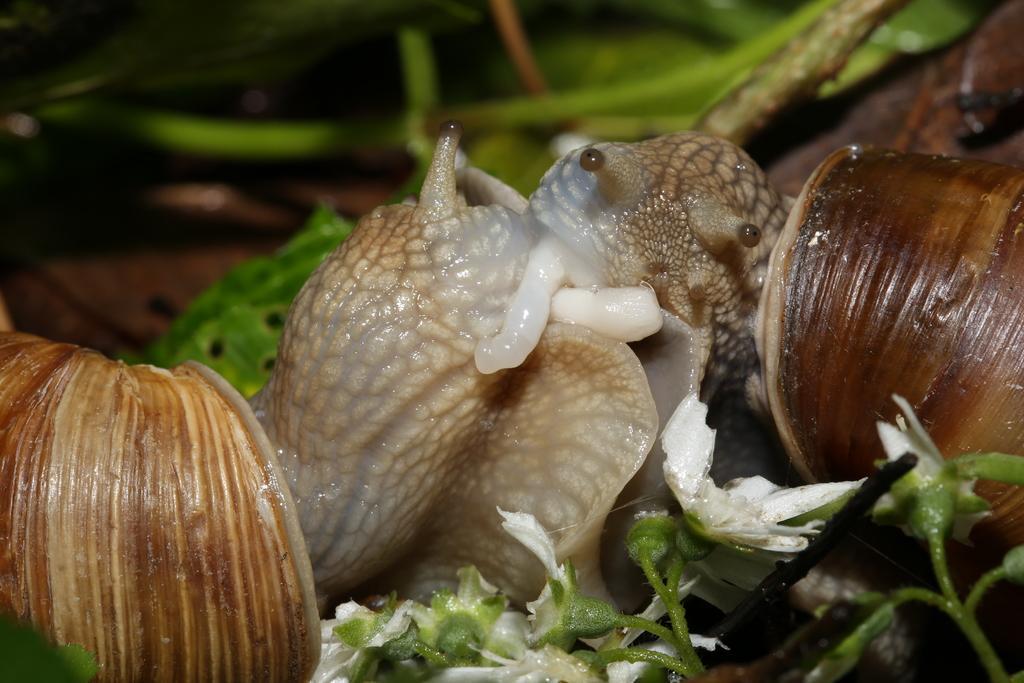Describe this image in one or two sentences. In this picture, we see snails and shells. At the bottom of the picture, we see a plant which has flowers. These flowers are in white color. In the background, it is green in color and it is blurred in the background. 